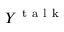<formula> <loc_0><loc_0><loc_500><loc_500>Y ^ { t a l k }</formula> 